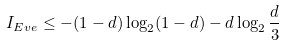Convert formula to latex. <formula><loc_0><loc_0><loc_500><loc_500>I _ { E v e } \leq - ( 1 - d ) \log _ { 2 } ( 1 - d ) - d \log _ { 2 } \frac { d } { 3 }</formula> 